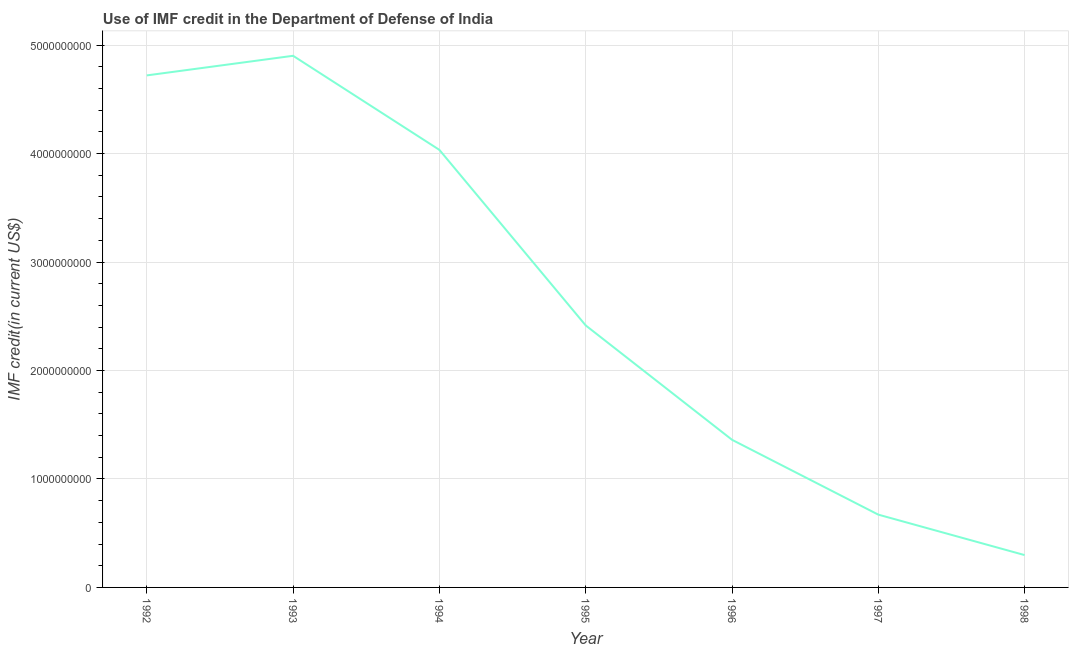What is the use of imf credit in dod in 1998?
Ensure brevity in your answer.  2.98e+08. Across all years, what is the maximum use of imf credit in dod?
Provide a short and direct response. 4.90e+09. Across all years, what is the minimum use of imf credit in dod?
Provide a succinct answer. 2.98e+08. In which year was the use of imf credit in dod maximum?
Your answer should be very brief. 1993. In which year was the use of imf credit in dod minimum?
Your answer should be compact. 1998. What is the sum of the use of imf credit in dod?
Your response must be concise. 1.84e+1. What is the difference between the use of imf credit in dod in 1992 and 1994?
Keep it short and to the point. 6.87e+08. What is the average use of imf credit in dod per year?
Offer a very short reply. 2.63e+09. What is the median use of imf credit in dod?
Offer a very short reply. 2.42e+09. What is the ratio of the use of imf credit in dod in 1992 to that in 1993?
Provide a short and direct response. 0.96. Is the use of imf credit in dod in 1995 less than that in 1998?
Your answer should be very brief. No. What is the difference between the highest and the second highest use of imf credit in dod?
Give a very brief answer. 1.81e+08. Is the sum of the use of imf credit in dod in 1992 and 1994 greater than the maximum use of imf credit in dod across all years?
Your response must be concise. Yes. What is the difference between the highest and the lowest use of imf credit in dod?
Make the answer very short. 4.60e+09. In how many years, is the use of imf credit in dod greater than the average use of imf credit in dod taken over all years?
Keep it short and to the point. 3. Does the use of imf credit in dod monotonically increase over the years?
Your answer should be very brief. No. How many lines are there?
Provide a succinct answer. 1. Does the graph contain any zero values?
Keep it short and to the point. No. Does the graph contain grids?
Make the answer very short. Yes. What is the title of the graph?
Ensure brevity in your answer.  Use of IMF credit in the Department of Defense of India. What is the label or title of the X-axis?
Make the answer very short. Year. What is the label or title of the Y-axis?
Offer a terse response. IMF credit(in current US$). What is the IMF credit(in current US$) in 1992?
Keep it short and to the point. 4.72e+09. What is the IMF credit(in current US$) in 1993?
Your answer should be compact. 4.90e+09. What is the IMF credit(in current US$) of 1994?
Ensure brevity in your answer.  4.03e+09. What is the IMF credit(in current US$) in 1995?
Provide a short and direct response. 2.42e+09. What is the IMF credit(in current US$) in 1996?
Offer a terse response. 1.36e+09. What is the IMF credit(in current US$) of 1997?
Offer a very short reply. 6.71e+08. What is the IMF credit(in current US$) of 1998?
Provide a short and direct response. 2.98e+08. What is the difference between the IMF credit(in current US$) in 1992 and 1993?
Your answer should be very brief. -1.81e+08. What is the difference between the IMF credit(in current US$) in 1992 and 1994?
Provide a short and direct response. 6.87e+08. What is the difference between the IMF credit(in current US$) in 1992 and 1995?
Offer a very short reply. 2.30e+09. What is the difference between the IMF credit(in current US$) in 1992 and 1996?
Give a very brief answer. 3.36e+09. What is the difference between the IMF credit(in current US$) in 1992 and 1997?
Provide a short and direct response. 4.05e+09. What is the difference between the IMF credit(in current US$) in 1992 and 1998?
Offer a very short reply. 4.42e+09. What is the difference between the IMF credit(in current US$) in 1993 and 1994?
Provide a short and direct response. 8.67e+08. What is the difference between the IMF credit(in current US$) in 1993 and 1995?
Provide a short and direct response. 2.49e+09. What is the difference between the IMF credit(in current US$) in 1993 and 1996?
Provide a succinct answer. 3.54e+09. What is the difference between the IMF credit(in current US$) in 1993 and 1997?
Provide a succinct answer. 4.23e+09. What is the difference between the IMF credit(in current US$) in 1993 and 1998?
Give a very brief answer. 4.60e+09. What is the difference between the IMF credit(in current US$) in 1994 and 1995?
Your answer should be very brief. 1.62e+09. What is the difference between the IMF credit(in current US$) in 1994 and 1996?
Your answer should be compact. 2.67e+09. What is the difference between the IMF credit(in current US$) in 1994 and 1997?
Your answer should be very brief. 3.36e+09. What is the difference between the IMF credit(in current US$) in 1994 and 1998?
Offer a terse response. 3.74e+09. What is the difference between the IMF credit(in current US$) in 1995 and 1996?
Keep it short and to the point. 1.05e+09. What is the difference between the IMF credit(in current US$) in 1995 and 1997?
Your response must be concise. 1.74e+09. What is the difference between the IMF credit(in current US$) in 1995 and 1998?
Offer a very short reply. 2.12e+09. What is the difference between the IMF credit(in current US$) in 1996 and 1997?
Ensure brevity in your answer.  6.90e+08. What is the difference between the IMF credit(in current US$) in 1996 and 1998?
Give a very brief answer. 1.06e+09. What is the difference between the IMF credit(in current US$) in 1997 and 1998?
Provide a short and direct response. 3.73e+08. What is the ratio of the IMF credit(in current US$) in 1992 to that in 1994?
Offer a terse response. 1.17. What is the ratio of the IMF credit(in current US$) in 1992 to that in 1995?
Your response must be concise. 1.95. What is the ratio of the IMF credit(in current US$) in 1992 to that in 1996?
Provide a succinct answer. 3.47. What is the ratio of the IMF credit(in current US$) in 1992 to that in 1997?
Offer a very short reply. 7.03. What is the ratio of the IMF credit(in current US$) in 1992 to that in 1998?
Offer a very short reply. 15.83. What is the ratio of the IMF credit(in current US$) in 1993 to that in 1994?
Your answer should be compact. 1.22. What is the ratio of the IMF credit(in current US$) in 1993 to that in 1995?
Give a very brief answer. 2.03. What is the ratio of the IMF credit(in current US$) in 1993 to that in 1996?
Offer a very short reply. 3.6. What is the ratio of the IMF credit(in current US$) in 1993 to that in 1997?
Your response must be concise. 7.3. What is the ratio of the IMF credit(in current US$) in 1993 to that in 1998?
Provide a short and direct response. 16.44. What is the ratio of the IMF credit(in current US$) in 1994 to that in 1995?
Provide a short and direct response. 1.67. What is the ratio of the IMF credit(in current US$) in 1994 to that in 1996?
Keep it short and to the point. 2.96. What is the ratio of the IMF credit(in current US$) in 1994 to that in 1997?
Ensure brevity in your answer.  6.01. What is the ratio of the IMF credit(in current US$) in 1994 to that in 1998?
Offer a very short reply. 13.53. What is the ratio of the IMF credit(in current US$) in 1995 to that in 1996?
Offer a terse response. 1.77. What is the ratio of the IMF credit(in current US$) in 1995 to that in 1997?
Give a very brief answer. 3.6. What is the ratio of the IMF credit(in current US$) in 1995 to that in 1998?
Provide a short and direct response. 8.1. What is the ratio of the IMF credit(in current US$) in 1996 to that in 1997?
Your answer should be very brief. 2.03. What is the ratio of the IMF credit(in current US$) in 1996 to that in 1998?
Your response must be concise. 4.57. What is the ratio of the IMF credit(in current US$) in 1997 to that in 1998?
Provide a short and direct response. 2.25. 